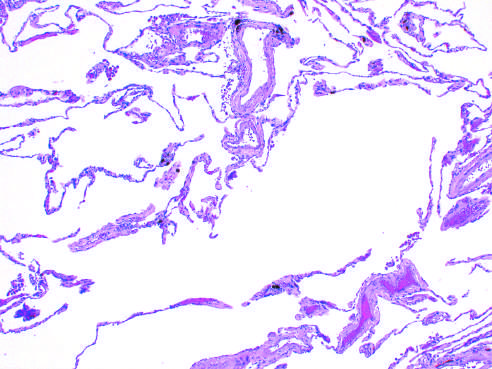how is marked enlargement of the air spaces?
Answer the question using a single word or phrase. With destruction alveolar septa but without fibrosis 